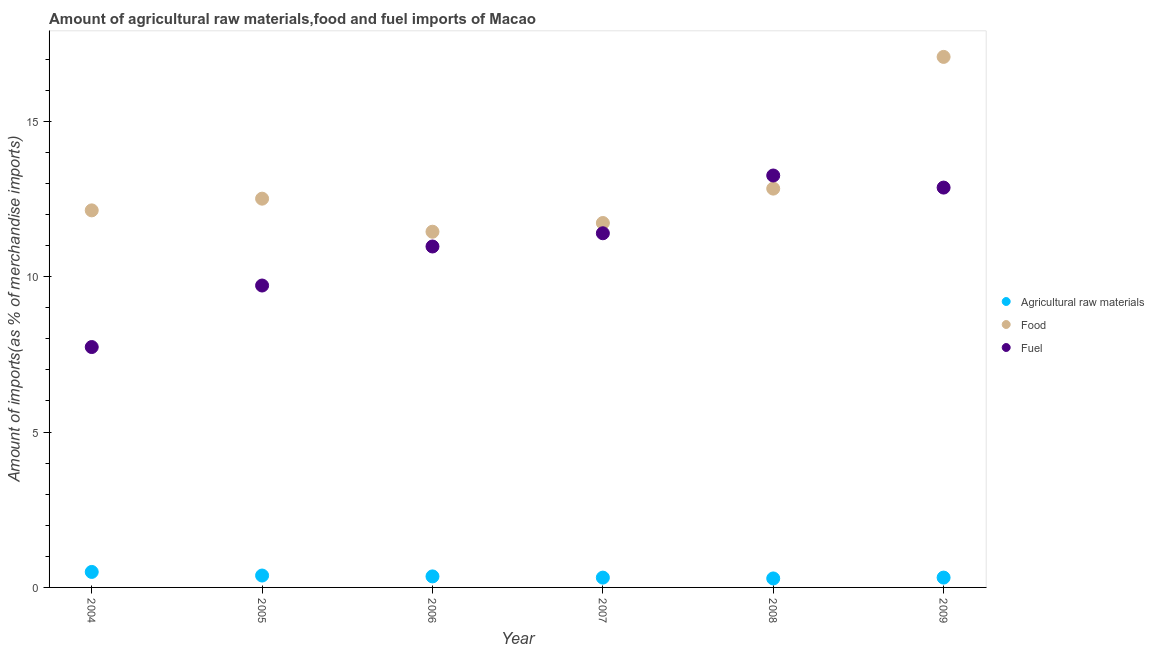What is the percentage of fuel imports in 2007?
Your response must be concise. 11.4. Across all years, what is the maximum percentage of food imports?
Keep it short and to the point. 17.07. Across all years, what is the minimum percentage of fuel imports?
Offer a terse response. 7.74. In which year was the percentage of food imports minimum?
Make the answer very short. 2006. What is the total percentage of raw materials imports in the graph?
Keep it short and to the point. 2.16. What is the difference between the percentage of food imports in 2006 and that in 2009?
Give a very brief answer. -5.63. What is the difference between the percentage of fuel imports in 2006 and the percentage of food imports in 2008?
Provide a succinct answer. -1.86. What is the average percentage of fuel imports per year?
Offer a terse response. 10.99. In the year 2005, what is the difference between the percentage of fuel imports and percentage of raw materials imports?
Your answer should be compact. 9.33. What is the ratio of the percentage of raw materials imports in 2005 to that in 2009?
Ensure brevity in your answer.  1.21. Is the difference between the percentage of fuel imports in 2005 and 2008 greater than the difference between the percentage of food imports in 2005 and 2008?
Your answer should be compact. No. What is the difference between the highest and the second highest percentage of raw materials imports?
Your answer should be compact. 0.12. What is the difference between the highest and the lowest percentage of food imports?
Make the answer very short. 5.63. Is the sum of the percentage of fuel imports in 2005 and 2006 greater than the maximum percentage of food imports across all years?
Ensure brevity in your answer.  Yes. Is the percentage of fuel imports strictly greater than the percentage of raw materials imports over the years?
Ensure brevity in your answer.  Yes. Is the percentage of raw materials imports strictly less than the percentage of fuel imports over the years?
Your answer should be very brief. Yes. How many dotlines are there?
Make the answer very short. 3. Are the values on the major ticks of Y-axis written in scientific E-notation?
Your answer should be very brief. No. Does the graph contain grids?
Ensure brevity in your answer.  No. Where does the legend appear in the graph?
Your answer should be very brief. Center right. How many legend labels are there?
Give a very brief answer. 3. How are the legend labels stacked?
Offer a very short reply. Vertical. What is the title of the graph?
Give a very brief answer. Amount of agricultural raw materials,food and fuel imports of Macao. What is the label or title of the X-axis?
Ensure brevity in your answer.  Year. What is the label or title of the Y-axis?
Your response must be concise. Amount of imports(as % of merchandise imports). What is the Amount of imports(as % of merchandise imports) of Agricultural raw materials in 2004?
Offer a very short reply. 0.5. What is the Amount of imports(as % of merchandise imports) in Food in 2004?
Your answer should be very brief. 12.13. What is the Amount of imports(as % of merchandise imports) of Fuel in 2004?
Offer a very short reply. 7.74. What is the Amount of imports(as % of merchandise imports) of Agricultural raw materials in 2005?
Offer a very short reply. 0.38. What is the Amount of imports(as % of merchandise imports) of Food in 2005?
Your answer should be very brief. 12.51. What is the Amount of imports(as % of merchandise imports) of Fuel in 2005?
Your response must be concise. 9.72. What is the Amount of imports(as % of merchandise imports) in Agricultural raw materials in 2006?
Provide a short and direct response. 0.35. What is the Amount of imports(as % of merchandise imports) in Food in 2006?
Your answer should be very brief. 11.45. What is the Amount of imports(as % of merchandise imports) in Fuel in 2006?
Ensure brevity in your answer.  10.97. What is the Amount of imports(as % of merchandise imports) of Agricultural raw materials in 2007?
Your response must be concise. 0.32. What is the Amount of imports(as % of merchandise imports) in Food in 2007?
Ensure brevity in your answer.  11.73. What is the Amount of imports(as % of merchandise imports) of Fuel in 2007?
Offer a very short reply. 11.4. What is the Amount of imports(as % of merchandise imports) in Agricultural raw materials in 2008?
Offer a terse response. 0.29. What is the Amount of imports(as % of merchandise imports) of Food in 2008?
Your answer should be very brief. 12.83. What is the Amount of imports(as % of merchandise imports) in Fuel in 2008?
Provide a short and direct response. 13.26. What is the Amount of imports(as % of merchandise imports) in Agricultural raw materials in 2009?
Your response must be concise. 0.32. What is the Amount of imports(as % of merchandise imports) of Food in 2009?
Ensure brevity in your answer.  17.07. What is the Amount of imports(as % of merchandise imports) of Fuel in 2009?
Offer a terse response. 12.87. Across all years, what is the maximum Amount of imports(as % of merchandise imports) in Agricultural raw materials?
Your response must be concise. 0.5. Across all years, what is the maximum Amount of imports(as % of merchandise imports) in Food?
Ensure brevity in your answer.  17.07. Across all years, what is the maximum Amount of imports(as % of merchandise imports) of Fuel?
Provide a succinct answer. 13.26. Across all years, what is the minimum Amount of imports(as % of merchandise imports) of Agricultural raw materials?
Provide a succinct answer. 0.29. Across all years, what is the minimum Amount of imports(as % of merchandise imports) of Food?
Your response must be concise. 11.45. Across all years, what is the minimum Amount of imports(as % of merchandise imports) of Fuel?
Ensure brevity in your answer.  7.74. What is the total Amount of imports(as % of merchandise imports) in Agricultural raw materials in the graph?
Offer a terse response. 2.16. What is the total Amount of imports(as % of merchandise imports) of Food in the graph?
Your answer should be very brief. 77.73. What is the total Amount of imports(as % of merchandise imports) of Fuel in the graph?
Provide a short and direct response. 65.94. What is the difference between the Amount of imports(as % of merchandise imports) of Agricultural raw materials in 2004 and that in 2005?
Provide a short and direct response. 0.12. What is the difference between the Amount of imports(as % of merchandise imports) of Food in 2004 and that in 2005?
Offer a very short reply. -0.38. What is the difference between the Amount of imports(as % of merchandise imports) of Fuel in 2004 and that in 2005?
Your answer should be compact. -1.98. What is the difference between the Amount of imports(as % of merchandise imports) in Agricultural raw materials in 2004 and that in 2006?
Your answer should be very brief. 0.14. What is the difference between the Amount of imports(as % of merchandise imports) in Food in 2004 and that in 2006?
Ensure brevity in your answer.  0.69. What is the difference between the Amount of imports(as % of merchandise imports) of Fuel in 2004 and that in 2006?
Keep it short and to the point. -3.24. What is the difference between the Amount of imports(as % of merchandise imports) of Agricultural raw materials in 2004 and that in 2007?
Give a very brief answer. 0.18. What is the difference between the Amount of imports(as % of merchandise imports) in Food in 2004 and that in 2007?
Offer a terse response. 0.41. What is the difference between the Amount of imports(as % of merchandise imports) of Fuel in 2004 and that in 2007?
Ensure brevity in your answer.  -3.66. What is the difference between the Amount of imports(as % of merchandise imports) of Agricultural raw materials in 2004 and that in 2008?
Ensure brevity in your answer.  0.21. What is the difference between the Amount of imports(as % of merchandise imports) of Food in 2004 and that in 2008?
Give a very brief answer. -0.7. What is the difference between the Amount of imports(as % of merchandise imports) of Fuel in 2004 and that in 2008?
Your response must be concise. -5.52. What is the difference between the Amount of imports(as % of merchandise imports) of Agricultural raw materials in 2004 and that in 2009?
Provide a succinct answer. 0.18. What is the difference between the Amount of imports(as % of merchandise imports) of Food in 2004 and that in 2009?
Offer a very short reply. -4.94. What is the difference between the Amount of imports(as % of merchandise imports) of Fuel in 2004 and that in 2009?
Provide a succinct answer. -5.13. What is the difference between the Amount of imports(as % of merchandise imports) of Agricultural raw materials in 2005 and that in 2006?
Provide a short and direct response. 0.03. What is the difference between the Amount of imports(as % of merchandise imports) in Food in 2005 and that in 2006?
Keep it short and to the point. 1.06. What is the difference between the Amount of imports(as % of merchandise imports) of Fuel in 2005 and that in 2006?
Provide a succinct answer. -1.26. What is the difference between the Amount of imports(as % of merchandise imports) in Agricultural raw materials in 2005 and that in 2007?
Offer a terse response. 0.07. What is the difference between the Amount of imports(as % of merchandise imports) in Food in 2005 and that in 2007?
Your answer should be very brief. 0.78. What is the difference between the Amount of imports(as % of merchandise imports) in Fuel in 2005 and that in 2007?
Provide a short and direct response. -1.68. What is the difference between the Amount of imports(as % of merchandise imports) in Agricultural raw materials in 2005 and that in 2008?
Make the answer very short. 0.09. What is the difference between the Amount of imports(as % of merchandise imports) of Food in 2005 and that in 2008?
Provide a short and direct response. -0.32. What is the difference between the Amount of imports(as % of merchandise imports) in Fuel in 2005 and that in 2008?
Offer a terse response. -3.54. What is the difference between the Amount of imports(as % of merchandise imports) in Agricultural raw materials in 2005 and that in 2009?
Your answer should be compact. 0.07. What is the difference between the Amount of imports(as % of merchandise imports) of Food in 2005 and that in 2009?
Provide a short and direct response. -4.56. What is the difference between the Amount of imports(as % of merchandise imports) in Fuel in 2005 and that in 2009?
Ensure brevity in your answer.  -3.15. What is the difference between the Amount of imports(as % of merchandise imports) of Agricultural raw materials in 2006 and that in 2007?
Offer a very short reply. 0.04. What is the difference between the Amount of imports(as % of merchandise imports) in Food in 2006 and that in 2007?
Ensure brevity in your answer.  -0.28. What is the difference between the Amount of imports(as % of merchandise imports) of Fuel in 2006 and that in 2007?
Keep it short and to the point. -0.43. What is the difference between the Amount of imports(as % of merchandise imports) in Agricultural raw materials in 2006 and that in 2008?
Your response must be concise. 0.07. What is the difference between the Amount of imports(as % of merchandise imports) of Food in 2006 and that in 2008?
Provide a short and direct response. -1.39. What is the difference between the Amount of imports(as % of merchandise imports) in Fuel in 2006 and that in 2008?
Provide a succinct answer. -2.28. What is the difference between the Amount of imports(as % of merchandise imports) of Agricultural raw materials in 2006 and that in 2009?
Offer a very short reply. 0.04. What is the difference between the Amount of imports(as % of merchandise imports) of Food in 2006 and that in 2009?
Offer a very short reply. -5.63. What is the difference between the Amount of imports(as % of merchandise imports) of Fuel in 2006 and that in 2009?
Your answer should be very brief. -1.9. What is the difference between the Amount of imports(as % of merchandise imports) in Agricultural raw materials in 2007 and that in 2008?
Your response must be concise. 0.03. What is the difference between the Amount of imports(as % of merchandise imports) in Food in 2007 and that in 2008?
Give a very brief answer. -1.11. What is the difference between the Amount of imports(as % of merchandise imports) in Fuel in 2007 and that in 2008?
Offer a terse response. -1.86. What is the difference between the Amount of imports(as % of merchandise imports) of Agricultural raw materials in 2007 and that in 2009?
Provide a succinct answer. -0. What is the difference between the Amount of imports(as % of merchandise imports) of Food in 2007 and that in 2009?
Offer a terse response. -5.35. What is the difference between the Amount of imports(as % of merchandise imports) in Fuel in 2007 and that in 2009?
Make the answer very short. -1.47. What is the difference between the Amount of imports(as % of merchandise imports) of Agricultural raw materials in 2008 and that in 2009?
Give a very brief answer. -0.03. What is the difference between the Amount of imports(as % of merchandise imports) of Food in 2008 and that in 2009?
Provide a succinct answer. -4.24. What is the difference between the Amount of imports(as % of merchandise imports) in Fuel in 2008 and that in 2009?
Give a very brief answer. 0.39. What is the difference between the Amount of imports(as % of merchandise imports) in Agricultural raw materials in 2004 and the Amount of imports(as % of merchandise imports) in Food in 2005?
Provide a succinct answer. -12.01. What is the difference between the Amount of imports(as % of merchandise imports) of Agricultural raw materials in 2004 and the Amount of imports(as % of merchandise imports) of Fuel in 2005?
Offer a terse response. -9.22. What is the difference between the Amount of imports(as % of merchandise imports) of Food in 2004 and the Amount of imports(as % of merchandise imports) of Fuel in 2005?
Provide a short and direct response. 2.42. What is the difference between the Amount of imports(as % of merchandise imports) of Agricultural raw materials in 2004 and the Amount of imports(as % of merchandise imports) of Food in 2006?
Your answer should be compact. -10.95. What is the difference between the Amount of imports(as % of merchandise imports) of Agricultural raw materials in 2004 and the Amount of imports(as % of merchandise imports) of Fuel in 2006?
Your answer should be compact. -10.47. What is the difference between the Amount of imports(as % of merchandise imports) in Food in 2004 and the Amount of imports(as % of merchandise imports) in Fuel in 2006?
Ensure brevity in your answer.  1.16. What is the difference between the Amount of imports(as % of merchandise imports) of Agricultural raw materials in 2004 and the Amount of imports(as % of merchandise imports) of Food in 2007?
Provide a succinct answer. -11.23. What is the difference between the Amount of imports(as % of merchandise imports) of Agricultural raw materials in 2004 and the Amount of imports(as % of merchandise imports) of Fuel in 2007?
Your response must be concise. -10.9. What is the difference between the Amount of imports(as % of merchandise imports) in Food in 2004 and the Amount of imports(as % of merchandise imports) in Fuel in 2007?
Your response must be concise. 0.74. What is the difference between the Amount of imports(as % of merchandise imports) of Agricultural raw materials in 2004 and the Amount of imports(as % of merchandise imports) of Food in 2008?
Offer a terse response. -12.34. What is the difference between the Amount of imports(as % of merchandise imports) of Agricultural raw materials in 2004 and the Amount of imports(as % of merchandise imports) of Fuel in 2008?
Offer a terse response. -12.76. What is the difference between the Amount of imports(as % of merchandise imports) in Food in 2004 and the Amount of imports(as % of merchandise imports) in Fuel in 2008?
Offer a very short reply. -1.12. What is the difference between the Amount of imports(as % of merchandise imports) of Agricultural raw materials in 2004 and the Amount of imports(as % of merchandise imports) of Food in 2009?
Ensure brevity in your answer.  -16.57. What is the difference between the Amount of imports(as % of merchandise imports) in Agricultural raw materials in 2004 and the Amount of imports(as % of merchandise imports) in Fuel in 2009?
Provide a short and direct response. -12.37. What is the difference between the Amount of imports(as % of merchandise imports) in Food in 2004 and the Amount of imports(as % of merchandise imports) in Fuel in 2009?
Make the answer very short. -0.73. What is the difference between the Amount of imports(as % of merchandise imports) in Agricultural raw materials in 2005 and the Amount of imports(as % of merchandise imports) in Food in 2006?
Ensure brevity in your answer.  -11.06. What is the difference between the Amount of imports(as % of merchandise imports) of Agricultural raw materials in 2005 and the Amount of imports(as % of merchandise imports) of Fuel in 2006?
Provide a succinct answer. -10.59. What is the difference between the Amount of imports(as % of merchandise imports) of Food in 2005 and the Amount of imports(as % of merchandise imports) of Fuel in 2006?
Ensure brevity in your answer.  1.54. What is the difference between the Amount of imports(as % of merchandise imports) in Agricultural raw materials in 2005 and the Amount of imports(as % of merchandise imports) in Food in 2007?
Ensure brevity in your answer.  -11.34. What is the difference between the Amount of imports(as % of merchandise imports) of Agricultural raw materials in 2005 and the Amount of imports(as % of merchandise imports) of Fuel in 2007?
Make the answer very short. -11.01. What is the difference between the Amount of imports(as % of merchandise imports) in Food in 2005 and the Amount of imports(as % of merchandise imports) in Fuel in 2007?
Provide a succinct answer. 1.11. What is the difference between the Amount of imports(as % of merchandise imports) of Agricultural raw materials in 2005 and the Amount of imports(as % of merchandise imports) of Food in 2008?
Provide a succinct answer. -12.45. What is the difference between the Amount of imports(as % of merchandise imports) in Agricultural raw materials in 2005 and the Amount of imports(as % of merchandise imports) in Fuel in 2008?
Your answer should be compact. -12.87. What is the difference between the Amount of imports(as % of merchandise imports) in Food in 2005 and the Amount of imports(as % of merchandise imports) in Fuel in 2008?
Your answer should be very brief. -0.75. What is the difference between the Amount of imports(as % of merchandise imports) in Agricultural raw materials in 2005 and the Amount of imports(as % of merchandise imports) in Food in 2009?
Your response must be concise. -16.69. What is the difference between the Amount of imports(as % of merchandise imports) of Agricultural raw materials in 2005 and the Amount of imports(as % of merchandise imports) of Fuel in 2009?
Provide a short and direct response. -12.48. What is the difference between the Amount of imports(as % of merchandise imports) of Food in 2005 and the Amount of imports(as % of merchandise imports) of Fuel in 2009?
Your answer should be very brief. -0.36. What is the difference between the Amount of imports(as % of merchandise imports) of Agricultural raw materials in 2006 and the Amount of imports(as % of merchandise imports) of Food in 2007?
Give a very brief answer. -11.37. What is the difference between the Amount of imports(as % of merchandise imports) in Agricultural raw materials in 2006 and the Amount of imports(as % of merchandise imports) in Fuel in 2007?
Keep it short and to the point. -11.04. What is the difference between the Amount of imports(as % of merchandise imports) in Food in 2006 and the Amount of imports(as % of merchandise imports) in Fuel in 2007?
Keep it short and to the point. 0.05. What is the difference between the Amount of imports(as % of merchandise imports) in Agricultural raw materials in 2006 and the Amount of imports(as % of merchandise imports) in Food in 2008?
Provide a succinct answer. -12.48. What is the difference between the Amount of imports(as % of merchandise imports) in Agricultural raw materials in 2006 and the Amount of imports(as % of merchandise imports) in Fuel in 2008?
Your answer should be compact. -12.9. What is the difference between the Amount of imports(as % of merchandise imports) in Food in 2006 and the Amount of imports(as % of merchandise imports) in Fuel in 2008?
Give a very brief answer. -1.81. What is the difference between the Amount of imports(as % of merchandise imports) in Agricultural raw materials in 2006 and the Amount of imports(as % of merchandise imports) in Food in 2009?
Your answer should be very brief. -16.72. What is the difference between the Amount of imports(as % of merchandise imports) of Agricultural raw materials in 2006 and the Amount of imports(as % of merchandise imports) of Fuel in 2009?
Offer a very short reply. -12.51. What is the difference between the Amount of imports(as % of merchandise imports) of Food in 2006 and the Amount of imports(as % of merchandise imports) of Fuel in 2009?
Your answer should be compact. -1.42. What is the difference between the Amount of imports(as % of merchandise imports) of Agricultural raw materials in 2007 and the Amount of imports(as % of merchandise imports) of Food in 2008?
Provide a short and direct response. -12.52. What is the difference between the Amount of imports(as % of merchandise imports) in Agricultural raw materials in 2007 and the Amount of imports(as % of merchandise imports) in Fuel in 2008?
Your answer should be compact. -12.94. What is the difference between the Amount of imports(as % of merchandise imports) in Food in 2007 and the Amount of imports(as % of merchandise imports) in Fuel in 2008?
Offer a terse response. -1.53. What is the difference between the Amount of imports(as % of merchandise imports) in Agricultural raw materials in 2007 and the Amount of imports(as % of merchandise imports) in Food in 2009?
Your answer should be very brief. -16.76. What is the difference between the Amount of imports(as % of merchandise imports) of Agricultural raw materials in 2007 and the Amount of imports(as % of merchandise imports) of Fuel in 2009?
Offer a very short reply. -12.55. What is the difference between the Amount of imports(as % of merchandise imports) of Food in 2007 and the Amount of imports(as % of merchandise imports) of Fuel in 2009?
Make the answer very short. -1.14. What is the difference between the Amount of imports(as % of merchandise imports) of Agricultural raw materials in 2008 and the Amount of imports(as % of merchandise imports) of Food in 2009?
Give a very brief answer. -16.78. What is the difference between the Amount of imports(as % of merchandise imports) of Agricultural raw materials in 2008 and the Amount of imports(as % of merchandise imports) of Fuel in 2009?
Your answer should be very brief. -12.58. What is the difference between the Amount of imports(as % of merchandise imports) in Food in 2008 and the Amount of imports(as % of merchandise imports) in Fuel in 2009?
Provide a short and direct response. -0.03. What is the average Amount of imports(as % of merchandise imports) in Agricultural raw materials per year?
Offer a very short reply. 0.36. What is the average Amount of imports(as % of merchandise imports) of Food per year?
Make the answer very short. 12.95. What is the average Amount of imports(as % of merchandise imports) of Fuel per year?
Keep it short and to the point. 10.99. In the year 2004, what is the difference between the Amount of imports(as % of merchandise imports) in Agricultural raw materials and Amount of imports(as % of merchandise imports) in Food?
Give a very brief answer. -11.64. In the year 2004, what is the difference between the Amount of imports(as % of merchandise imports) of Agricultural raw materials and Amount of imports(as % of merchandise imports) of Fuel?
Make the answer very short. -7.24. In the year 2004, what is the difference between the Amount of imports(as % of merchandise imports) of Food and Amount of imports(as % of merchandise imports) of Fuel?
Give a very brief answer. 4.4. In the year 2005, what is the difference between the Amount of imports(as % of merchandise imports) of Agricultural raw materials and Amount of imports(as % of merchandise imports) of Food?
Your answer should be compact. -12.13. In the year 2005, what is the difference between the Amount of imports(as % of merchandise imports) of Agricultural raw materials and Amount of imports(as % of merchandise imports) of Fuel?
Your answer should be compact. -9.33. In the year 2005, what is the difference between the Amount of imports(as % of merchandise imports) in Food and Amount of imports(as % of merchandise imports) in Fuel?
Your response must be concise. 2.8. In the year 2006, what is the difference between the Amount of imports(as % of merchandise imports) of Agricultural raw materials and Amount of imports(as % of merchandise imports) of Food?
Offer a terse response. -11.09. In the year 2006, what is the difference between the Amount of imports(as % of merchandise imports) of Agricultural raw materials and Amount of imports(as % of merchandise imports) of Fuel?
Your response must be concise. -10.62. In the year 2006, what is the difference between the Amount of imports(as % of merchandise imports) of Food and Amount of imports(as % of merchandise imports) of Fuel?
Ensure brevity in your answer.  0.48. In the year 2007, what is the difference between the Amount of imports(as % of merchandise imports) of Agricultural raw materials and Amount of imports(as % of merchandise imports) of Food?
Offer a very short reply. -11.41. In the year 2007, what is the difference between the Amount of imports(as % of merchandise imports) in Agricultural raw materials and Amount of imports(as % of merchandise imports) in Fuel?
Your response must be concise. -11.08. In the year 2007, what is the difference between the Amount of imports(as % of merchandise imports) in Food and Amount of imports(as % of merchandise imports) in Fuel?
Keep it short and to the point. 0.33. In the year 2008, what is the difference between the Amount of imports(as % of merchandise imports) of Agricultural raw materials and Amount of imports(as % of merchandise imports) of Food?
Offer a very short reply. -12.55. In the year 2008, what is the difference between the Amount of imports(as % of merchandise imports) in Agricultural raw materials and Amount of imports(as % of merchandise imports) in Fuel?
Your response must be concise. -12.97. In the year 2008, what is the difference between the Amount of imports(as % of merchandise imports) in Food and Amount of imports(as % of merchandise imports) in Fuel?
Offer a very short reply. -0.42. In the year 2009, what is the difference between the Amount of imports(as % of merchandise imports) of Agricultural raw materials and Amount of imports(as % of merchandise imports) of Food?
Offer a terse response. -16.76. In the year 2009, what is the difference between the Amount of imports(as % of merchandise imports) in Agricultural raw materials and Amount of imports(as % of merchandise imports) in Fuel?
Keep it short and to the point. -12.55. In the year 2009, what is the difference between the Amount of imports(as % of merchandise imports) of Food and Amount of imports(as % of merchandise imports) of Fuel?
Make the answer very short. 4.21. What is the ratio of the Amount of imports(as % of merchandise imports) in Agricultural raw materials in 2004 to that in 2005?
Offer a very short reply. 1.3. What is the ratio of the Amount of imports(as % of merchandise imports) in Food in 2004 to that in 2005?
Provide a succinct answer. 0.97. What is the ratio of the Amount of imports(as % of merchandise imports) in Fuel in 2004 to that in 2005?
Keep it short and to the point. 0.8. What is the ratio of the Amount of imports(as % of merchandise imports) in Agricultural raw materials in 2004 to that in 2006?
Offer a terse response. 1.41. What is the ratio of the Amount of imports(as % of merchandise imports) of Food in 2004 to that in 2006?
Keep it short and to the point. 1.06. What is the ratio of the Amount of imports(as % of merchandise imports) of Fuel in 2004 to that in 2006?
Provide a short and direct response. 0.71. What is the ratio of the Amount of imports(as % of merchandise imports) of Agricultural raw materials in 2004 to that in 2007?
Give a very brief answer. 1.58. What is the ratio of the Amount of imports(as % of merchandise imports) in Food in 2004 to that in 2007?
Make the answer very short. 1.03. What is the ratio of the Amount of imports(as % of merchandise imports) of Fuel in 2004 to that in 2007?
Your answer should be compact. 0.68. What is the ratio of the Amount of imports(as % of merchandise imports) of Agricultural raw materials in 2004 to that in 2008?
Your answer should be compact. 1.73. What is the ratio of the Amount of imports(as % of merchandise imports) of Food in 2004 to that in 2008?
Make the answer very short. 0.95. What is the ratio of the Amount of imports(as % of merchandise imports) of Fuel in 2004 to that in 2008?
Offer a very short reply. 0.58. What is the ratio of the Amount of imports(as % of merchandise imports) in Agricultural raw materials in 2004 to that in 2009?
Provide a succinct answer. 1.58. What is the ratio of the Amount of imports(as % of merchandise imports) of Food in 2004 to that in 2009?
Ensure brevity in your answer.  0.71. What is the ratio of the Amount of imports(as % of merchandise imports) of Fuel in 2004 to that in 2009?
Your answer should be compact. 0.6. What is the ratio of the Amount of imports(as % of merchandise imports) in Agricultural raw materials in 2005 to that in 2006?
Offer a very short reply. 1.08. What is the ratio of the Amount of imports(as % of merchandise imports) in Food in 2005 to that in 2006?
Ensure brevity in your answer.  1.09. What is the ratio of the Amount of imports(as % of merchandise imports) in Fuel in 2005 to that in 2006?
Your answer should be very brief. 0.89. What is the ratio of the Amount of imports(as % of merchandise imports) in Agricultural raw materials in 2005 to that in 2007?
Offer a terse response. 1.21. What is the ratio of the Amount of imports(as % of merchandise imports) in Food in 2005 to that in 2007?
Offer a terse response. 1.07. What is the ratio of the Amount of imports(as % of merchandise imports) in Fuel in 2005 to that in 2007?
Your answer should be compact. 0.85. What is the ratio of the Amount of imports(as % of merchandise imports) in Agricultural raw materials in 2005 to that in 2008?
Your response must be concise. 1.32. What is the ratio of the Amount of imports(as % of merchandise imports) in Food in 2005 to that in 2008?
Offer a terse response. 0.97. What is the ratio of the Amount of imports(as % of merchandise imports) of Fuel in 2005 to that in 2008?
Ensure brevity in your answer.  0.73. What is the ratio of the Amount of imports(as % of merchandise imports) in Agricultural raw materials in 2005 to that in 2009?
Provide a short and direct response. 1.21. What is the ratio of the Amount of imports(as % of merchandise imports) of Food in 2005 to that in 2009?
Make the answer very short. 0.73. What is the ratio of the Amount of imports(as % of merchandise imports) in Fuel in 2005 to that in 2009?
Your answer should be compact. 0.76. What is the ratio of the Amount of imports(as % of merchandise imports) in Agricultural raw materials in 2006 to that in 2007?
Make the answer very short. 1.12. What is the ratio of the Amount of imports(as % of merchandise imports) of Food in 2006 to that in 2007?
Keep it short and to the point. 0.98. What is the ratio of the Amount of imports(as % of merchandise imports) in Fuel in 2006 to that in 2007?
Make the answer very short. 0.96. What is the ratio of the Amount of imports(as % of merchandise imports) of Agricultural raw materials in 2006 to that in 2008?
Provide a succinct answer. 1.23. What is the ratio of the Amount of imports(as % of merchandise imports) of Food in 2006 to that in 2008?
Your answer should be compact. 0.89. What is the ratio of the Amount of imports(as % of merchandise imports) of Fuel in 2006 to that in 2008?
Give a very brief answer. 0.83. What is the ratio of the Amount of imports(as % of merchandise imports) in Agricultural raw materials in 2006 to that in 2009?
Give a very brief answer. 1.12. What is the ratio of the Amount of imports(as % of merchandise imports) of Food in 2006 to that in 2009?
Offer a terse response. 0.67. What is the ratio of the Amount of imports(as % of merchandise imports) in Fuel in 2006 to that in 2009?
Provide a succinct answer. 0.85. What is the ratio of the Amount of imports(as % of merchandise imports) in Agricultural raw materials in 2007 to that in 2008?
Keep it short and to the point. 1.09. What is the ratio of the Amount of imports(as % of merchandise imports) in Food in 2007 to that in 2008?
Provide a succinct answer. 0.91. What is the ratio of the Amount of imports(as % of merchandise imports) of Fuel in 2007 to that in 2008?
Provide a short and direct response. 0.86. What is the ratio of the Amount of imports(as % of merchandise imports) in Agricultural raw materials in 2007 to that in 2009?
Provide a succinct answer. 1. What is the ratio of the Amount of imports(as % of merchandise imports) in Food in 2007 to that in 2009?
Your answer should be compact. 0.69. What is the ratio of the Amount of imports(as % of merchandise imports) of Fuel in 2007 to that in 2009?
Provide a short and direct response. 0.89. What is the ratio of the Amount of imports(as % of merchandise imports) in Agricultural raw materials in 2008 to that in 2009?
Keep it short and to the point. 0.91. What is the ratio of the Amount of imports(as % of merchandise imports) in Food in 2008 to that in 2009?
Offer a terse response. 0.75. What is the ratio of the Amount of imports(as % of merchandise imports) in Fuel in 2008 to that in 2009?
Offer a very short reply. 1.03. What is the difference between the highest and the second highest Amount of imports(as % of merchandise imports) in Agricultural raw materials?
Your answer should be compact. 0.12. What is the difference between the highest and the second highest Amount of imports(as % of merchandise imports) in Food?
Offer a very short reply. 4.24. What is the difference between the highest and the second highest Amount of imports(as % of merchandise imports) in Fuel?
Provide a short and direct response. 0.39. What is the difference between the highest and the lowest Amount of imports(as % of merchandise imports) of Agricultural raw materials?
Your answer should be compact. 0.21. What is the difference between the highest and the lowest Amount of imports(as % of merchandise imports) in Food?
Ensure brevity in your answer.  5.63. What is the difference between the highest and the lowest Amount of imports(as % of merchandise imports) of Fuel?
Ensure brevity in your answer.  5.52. 